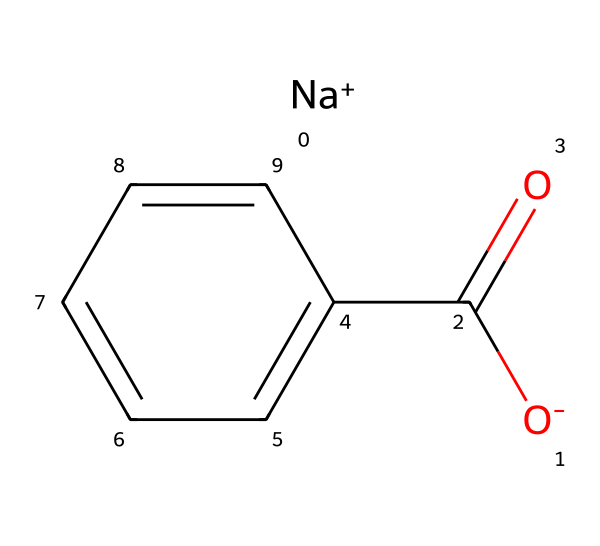What is the chemical name of this compound? The SMILES representation indicates that this compound is composed of a sodium ion, a carboxylate group, and a benzene ring. The overall structure corresponds to sodium benzoate, which is a common food preservative.
Answer: sodium benzoate How many carbon atoms are present in this molecule? By analyzing the SMILES representation, we count three parts: one from the carboxylate group (C(=O)) and six from the benzene ring (c1ccccc1), resulting in a total of seven carbon atoms.
Answer: seven What type of bond connects the sodium ion to the rest of the molecule? The sodium ion (Na+) is ionically bonded to the negatively charged carboxylate group ([O-]C(=O)), characteristic of salts. This involves the electrostatic attraction between the positive and negative charges.
Answer: ionic bond How many oxygen atoms are in sodium benzoate? The SMILES representation shows one oxygen in the carboxylate group (C(=O)) and another oxygen in the ionized form ([O-]), resulting in a total of two oxygen atoms in the compound.
Answer: two What functional group is present in sodium benzoate? The carboxylate part of the sodium benzoate, as evidenced by the C(=O) and [O-] in the SMILES, displays characteristics of the carboxylic acid functional group, specifically in its deprotonated form.
Answer: carboxylate Is sodium benzoate soluble in water? Sodium benzoate contains an ionic sodium ion and a polar carboxylate group, which typically indicates good solubility in water due to its ability to form favorable interactions with water molecules.
Answer: soluble 